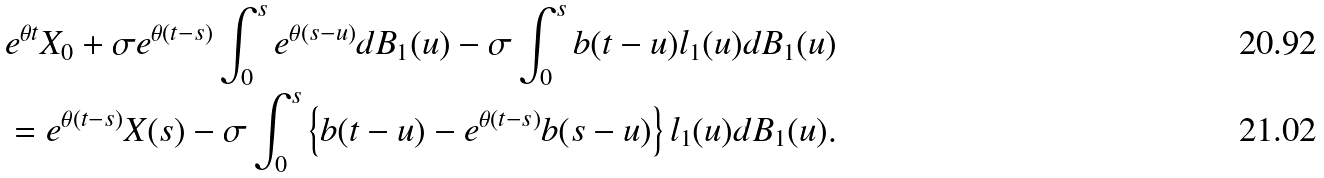Convert formula to latex. <formula><loc_0><loc_0><loc_500><loc_500>& e ^ { \theta t } X _ { 0 } + \sigma e ^ { \theta ( t - s ) } \int _ { 0 } ^ { s } e ^ { \theta ( s - u ) } d B _ { 1 } ( u ) - \sigma \int _ { 0 } ^ { s } b ( t - u ) l _ { 1 } ( u ) d B _ { 1 } ( u ) \\ & = e ^ { \theta ( t - s ) } X ( s ) - \sigma \int _ { 0 } ^ { s } \left \{ b ( t - u ) - e ^ { \theta ( t - s ) } b ( s - u ) \right \} l _ { 1 } ( u ) d B _ { 1 } ( u ) .</formula> 